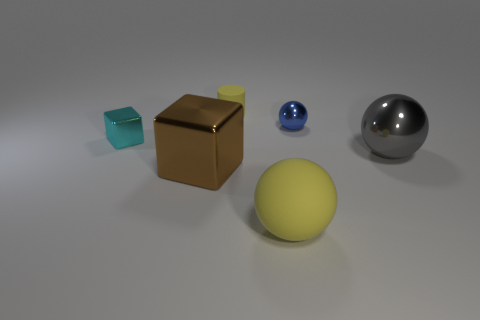There is a large object that is the same color as the small rubber object; what is its material?
Make the answer very short. Rubber. Is there any other thing that has the same size as the cylinder?
Provide a succinct answer. Yes. What number of other things are there of the same material as the cyan cube
Ensure brevity in your answer.  3. Is there another small cylinder that has the same color as the tiny matte cylinder?
Your answer should be very brief. No. There is a cyan shiny thing that is the same size as the blue object; what is its shape?
Ensure brevity in your answer.  Cube. How many blue objects are either matte balls or tiny objects?
Offer a very short reply. 1. How many cylinders have the same size as the brown metallic block?
Your response must be concise. 0. What is the shape of the object that is the same color as the cylinder?
Offer a very short reply. Sphere. How many objects are gray rubber cubes or shiny objects that are right of the small cyan thing?
Make the answer very short. 3. There is a rubber object in front of the tiny blue sphere; is it the same size as the blue sphere behind the large brown metallic thing?
Your answer should be compact. No. 